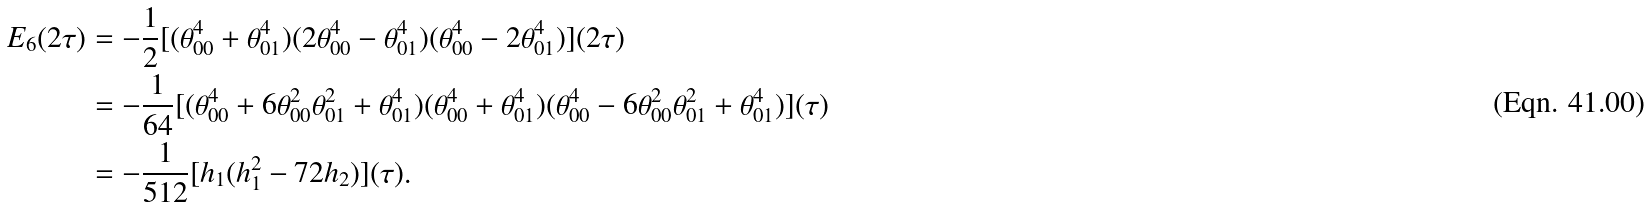<formula> <loc_0><loc_0><loc_500><loc_500>E _ { 6 } ( 2 \tau ) & = - \frac { 1 } { 2 } [ ( \theta _ { 0 0 } ^ { 4 } + \theta _ { 0 1 } ^ { 4 } ) ( 2 \theta _ { 0 0 } ^ { 4 } - \theta _ { 0 1 } ^ { 4 } ) ( \theta _ { 0 0 } ^ { 4 } - 2 \theta _ { 0 1 } ^ { 4 } ) ] ( 2 \tau ) \\ & = - \frac { 1 } { 6 4 } [ ( \theta _ { 0 0 } ^ { 4 } + 6 \theta _ { 0 0 } ^ { 2 } \theta _ { 0 1 } ^ { 2 } + \theta _ { 0 1 } ^ { 4 } ) ( \theta _ { 0 0 } ^ { 4 } + \theta _ { 0 1 } ^ { 4 } ) ( \theta _ { 0 0 } ^ { 4 } - 6 \theta _ { 0 0 } ^ { 2 } \theta _ { 0 1 } ^ { 2 } + \theta _ { 0 1 } ^ { 4 } ) ] ( \tau ) \\ & = - \frac { 1 } { 5 1 2 } [ h _ { 1 } ( h _ { 1 } ^ { 2 } - 7 2 h _ { 2 } ) ] ( \tau ) .</formula> 